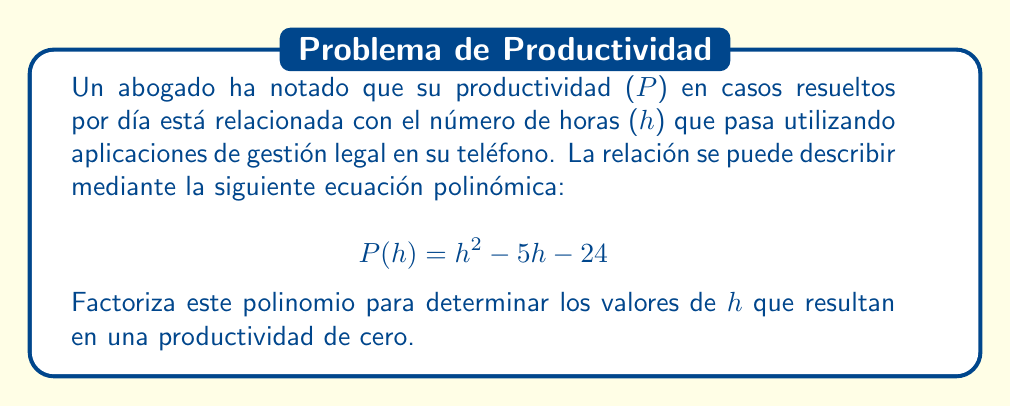Solve this math problem. Para factorizar este polinomio cuadrático, seguiremos estos pasos:

1) Identificamos la forma general del polinomio: $ah^2 + bh + c$
   En este caso, $a=1$, $b=-5$, y $c=-24$

2) Buscamos dos números cuyo producto sea $ac$ y cuya suma sea $b$:
   $ac = (1)(-24) = -24$
   Necesitamos encontrar dos números que multiplicados den -24 y sumados den -5
   Estos números son -8 y 3

3) Reescribimos el término medio usando estos números:
   $$ h^2 - 5h - 24 = h^2 - 8h + 3h - 24 $$

4) Agrupamos los términos:
   $$ (h^2 - 8h) + (3h - 24) $$

5) Factorizamos por grupos:
   $$ h(h - 8) + 3(h - 8) $$

6) Identificamos el factor común (h - 8):
   $$ (h - 8)(h + 3) $$

Esta es la forma factorizada del polinomio. Los valores de h que resultan en una productividad de cero son las soluciones de la ecuación $P(h) = 0$, que son los valores que hacen que cada factor sea igual a cero.
Answer: $(h - 8)(h + 3)$; $h = 8$ o $h = -3$ 